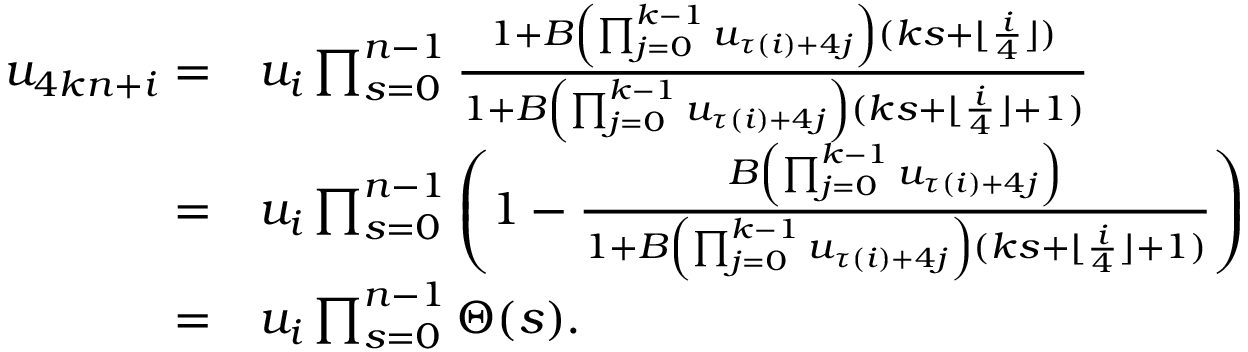Convert formula to latex. <formula><loc_0><loc_0><loc_500><loc_500>\begin{array} { r l } { u _ { 4 k n + i } = } & { u _ { i } \prod _ { s = 0 } ^ { n - 1 } \frac { 1 + B \left ( \prod _ { j = 0 } ^ { k - 1 } { u _ { \tau ( i ) + 4 j } } \right ) ( k s + \lfloor \frac { i } { 4 } \rfloor ) } { 1 + B \left ( \prod _ { j = 0 } ^ { k - 1 } { u _ { \tau ( i ) + 4 j } } \right ) ( k s + \lfloor \frac { i } { 4 } \rfloor + 1 ) } } \\ { = } & { u _ { i } \prod _ { s = 0 } ^ { n - 1 } \left ( 1 - \frac { B \left ( \prod _ { j = 0 } ^ { k - 1 } { u _ { \tau ( i ) + 4 j } } \right ) } { 1 + B \left ( \prod _ { j = 0 } ^ { k - 1 } { u _ { \tau ( i ) + 4 j } } \right ) ( k s + \lfloor \frac { i } { 4 } \rfloor + 1 ) } \right ) } \\ { = } & { u _ { i } \prod _ { s = 0 } ^ { n - 1 } \Theta ( s ) . } \end{array}</formula> 